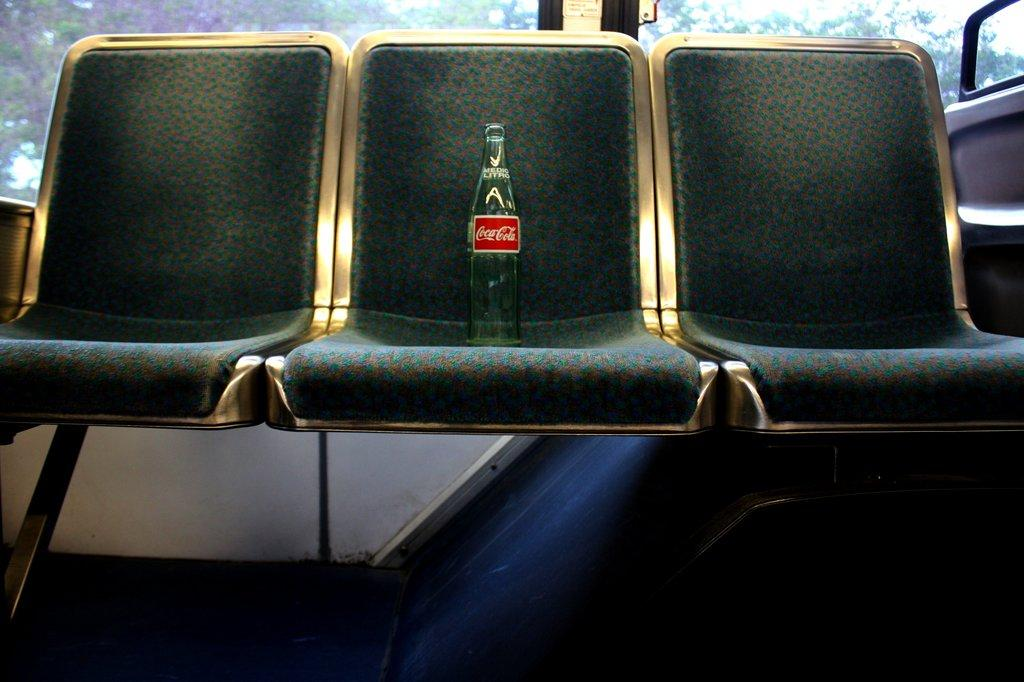What type of furniture is present in the image? There are chairs in the image. What is placed at the center of the chairs? There is a beverage bottle placed at the center of the chairs. What can be seen in the background of the image? There is a window in the backdrop of the image. What is visible through the window? Trees are visible from the window. Can you see a kite flying in the image? There is no kite visible in the image. What hope does the worm have in the image? There is no worm present in the image, so it is not possible to discuss its hopes. 